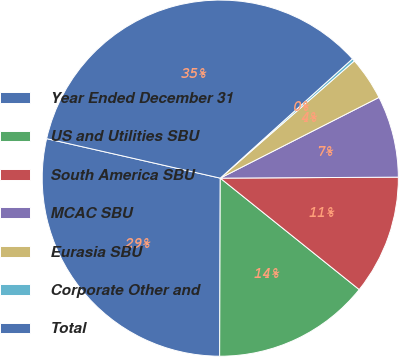Convert chart. <chart><loc_0><loc_0><loc_500><loc_500><pie_chart><fcel>Year Ended December 31<fcel>US and Utilities SBU<fcel>South America SBU<fcel>MCAC SBU<fcel>Eurasia SBU<fcel>Corporate Other and<fcel>Total<nl><fcel>28.51%<fcel>14.3%<fcel>10.85%<fcel>7.4%<fcel>3.95%<fcel>0.25%<fcel>34.76%<nl></chart> 